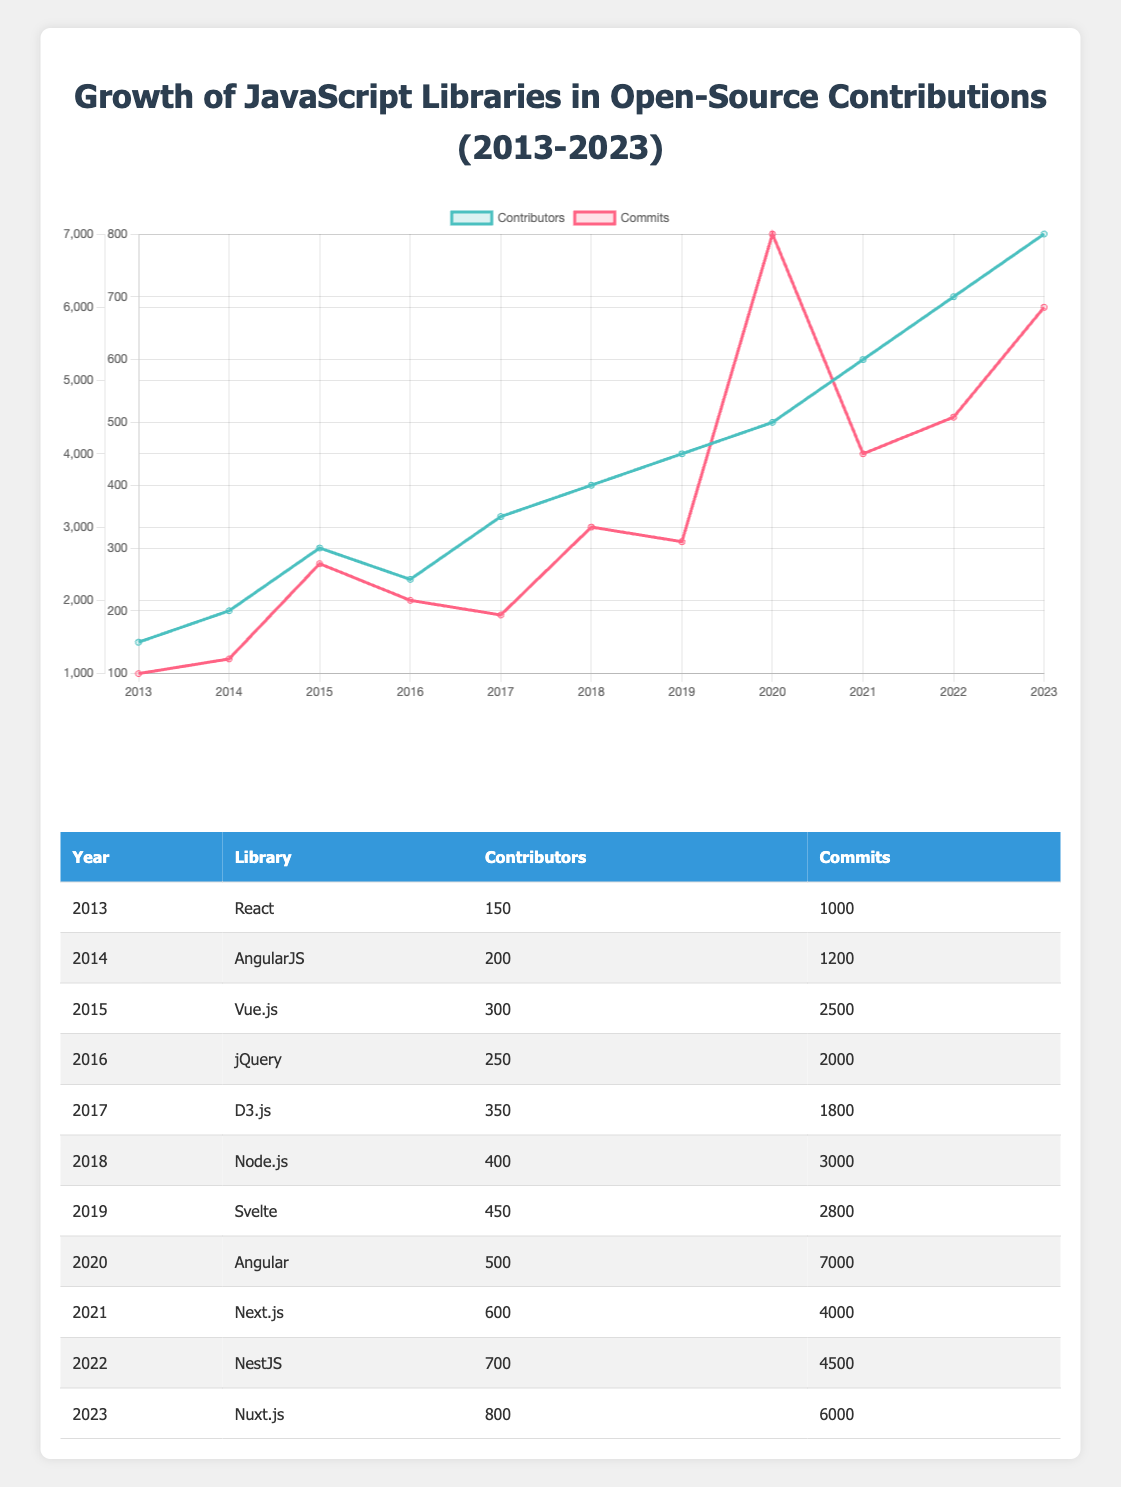What was the total number of contributors from 2013 to 2023? To calculate the total number of contributors, we sum the contributors for each year: 150 + 200 + 300 + 250 + 350 + 400 + 450 + 500 + 600 + 700 + 800 = 3950.
Answer: 3950 Which library had the highest number of commits in a single year? Looking through the commits for each library, Angular had the highest number of commits in 2020 with 7000 commits.
Answer: Angular (7000 commits in 2020) In which year did Vue.js have the least number of contributors? From the data, Vue.js has contributors only in 2015; thus, it is the only year and has 300 contributors, so it had the least number of contributors only in that year.
Answer: 2015 Was there an increase in both contributors and commits from 2017 to 2018? In 2017, there were 350 contributors and 1800 commits. In 2018, contributors increased to 400, and commits increased to 3000, indicating an increase in both metrics.
Answer: Yes What is the average number of commits per contributor for all years combined? First, sum the total commits: 1000 + 1200 + 2500 + 2000 + 1800 + 3000 + 2800 + 7000 + 4000 + 4500 + 6000 = 28000. The total number of contributors is 3950. Now divide 28000 by 3950, resulting in approximately 7.1 commits per contributor.
Answer: 7.1 In which year did the number of contributors first exceed 500? Reviewing the data, contributors exceeded 500 starting in 2020 when the count was 500.
Answer: 2020 Was the growth of commits linear over the years? Analyzing the commits, there are jumps in numbers with a significant increase in 2020 and fluctuations. Therefore, growth was not linear.
Answer: No Which library showed the most consistent increase in contributors over the years? Examining the data, Node.js and Nuxt.js consistently increased the number of contributors each year without any decline.
Answer: Node.js and Nuxt.js 